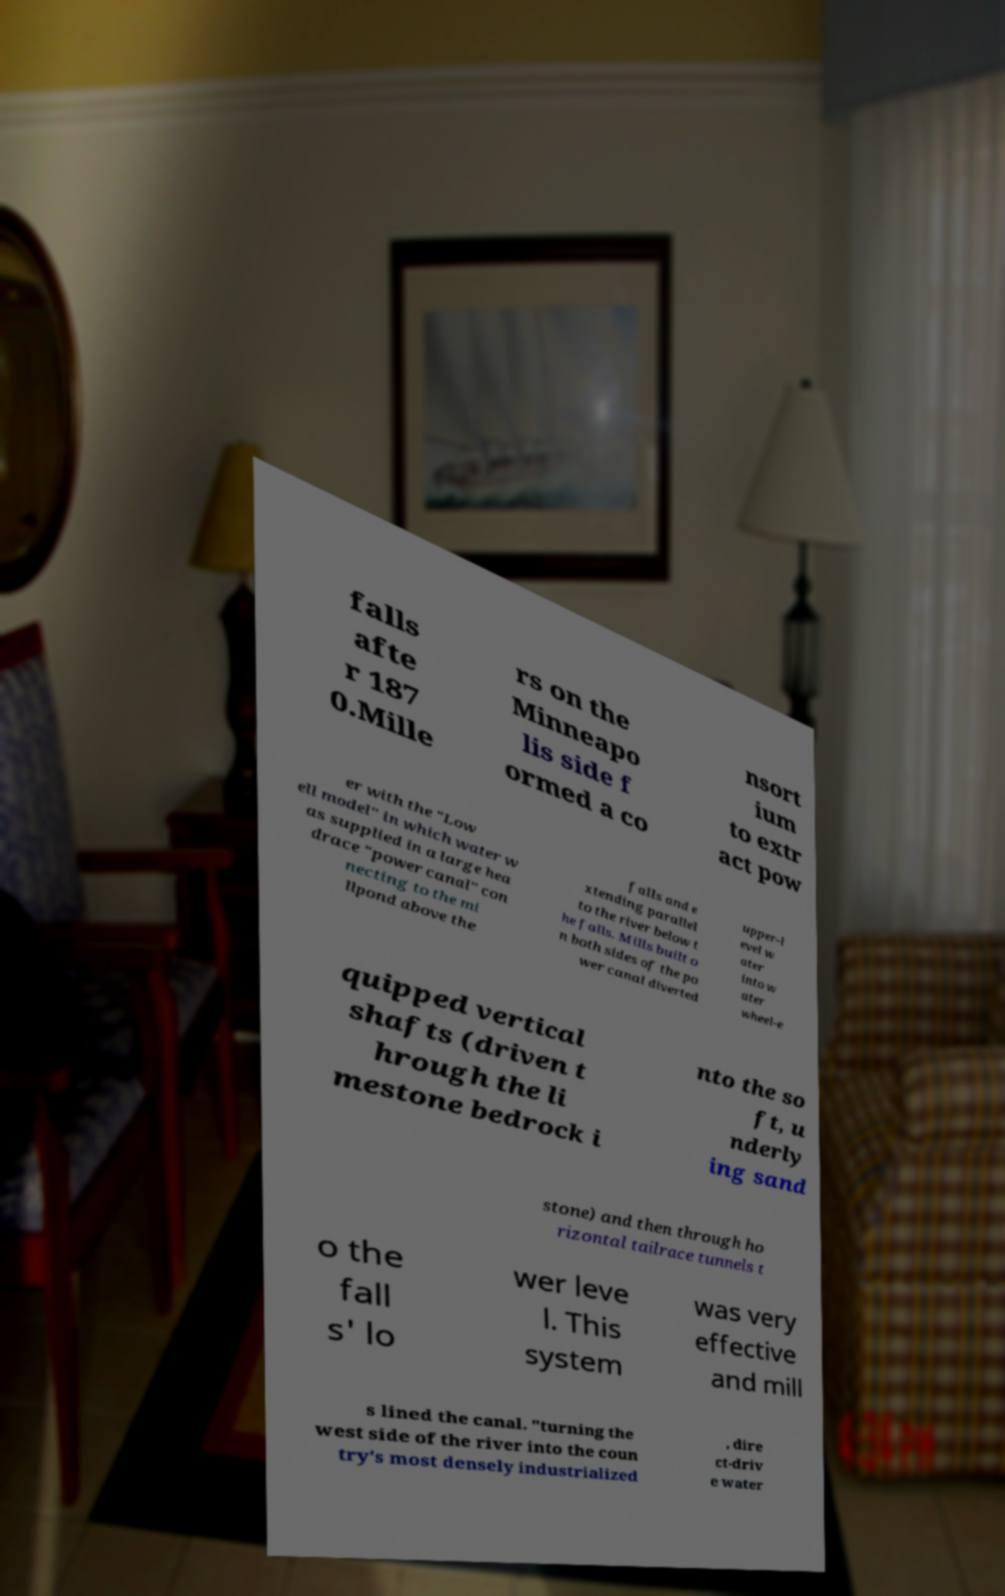For documentation purposes, I need the text within this image transcribed. Could you provide that? falls afte r 187 0.Mille rs on the Minneapo lis side f ormed a co nsort ium to extr act pow er with the "Low ell model" in which water w as supplied in a large hea drace "power canal" con necting to the mi llpond above the falls and e xtending parallel to the river below t he falls. Mills built o n both sides of the po wer canal diverted upper-l evel w ater into w ater wheel-e quipped vertical shafts (driven t hrough the li mestone bedrock i nto the so ft, u nderly ing sand stone) and then through ho rizontal tailrace tunnels t o the fall s' lo wer leve l. This system was very effective and mill s lined the canal. "turning the west side of the river into the coun try's most densely industrialized , dire ct-driv e water 